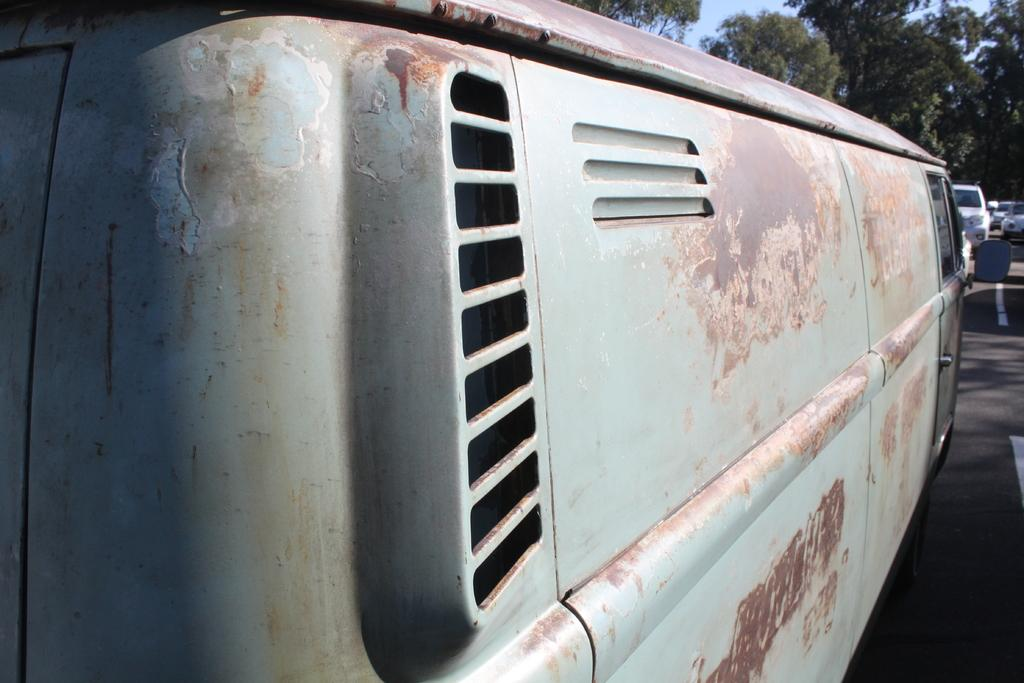What types of objects can be seen in the image? There are vehicles and trees in the image. What can be seen above the objects in the image? The sky is visible in the image. What is the surface on which the vehicles are traveling? There is a road in the image. What type of celery can be seen growing on the side of the road in the image? There is no celery present in the image; it features vehicles, trees, and a road. How does the yoke help the vehicles in the image? There is no yoke present in the image, as it is focused on vehicles, trees, the sky, and the road. 